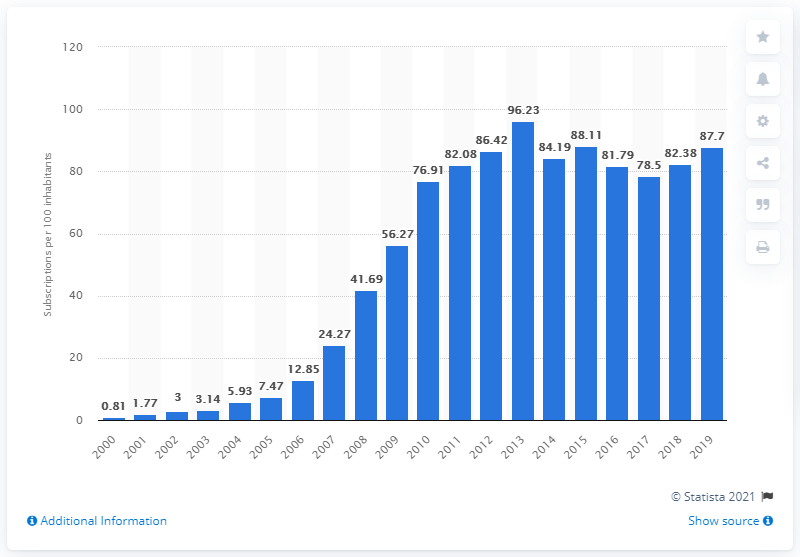Indicate a few pertinent items in this graphic. In Benin, between 2000 and 2019, there were an average of 87.7 mobile subscriptions for every 100 people. 